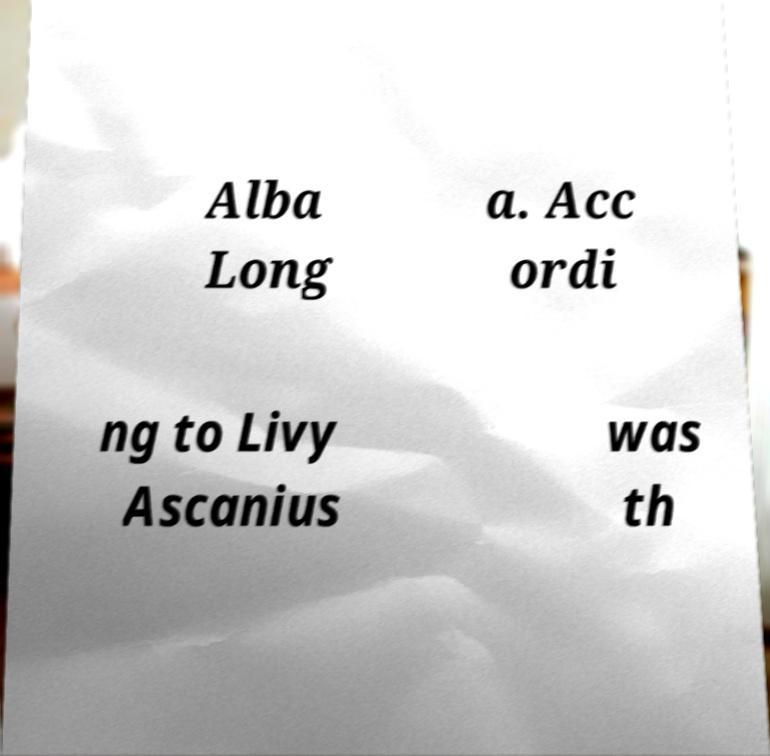What messages or text are displayed in this image? I need them in a readable, typed format. Alba Long a. Acc ordi ng to Livy Ascanius was th 